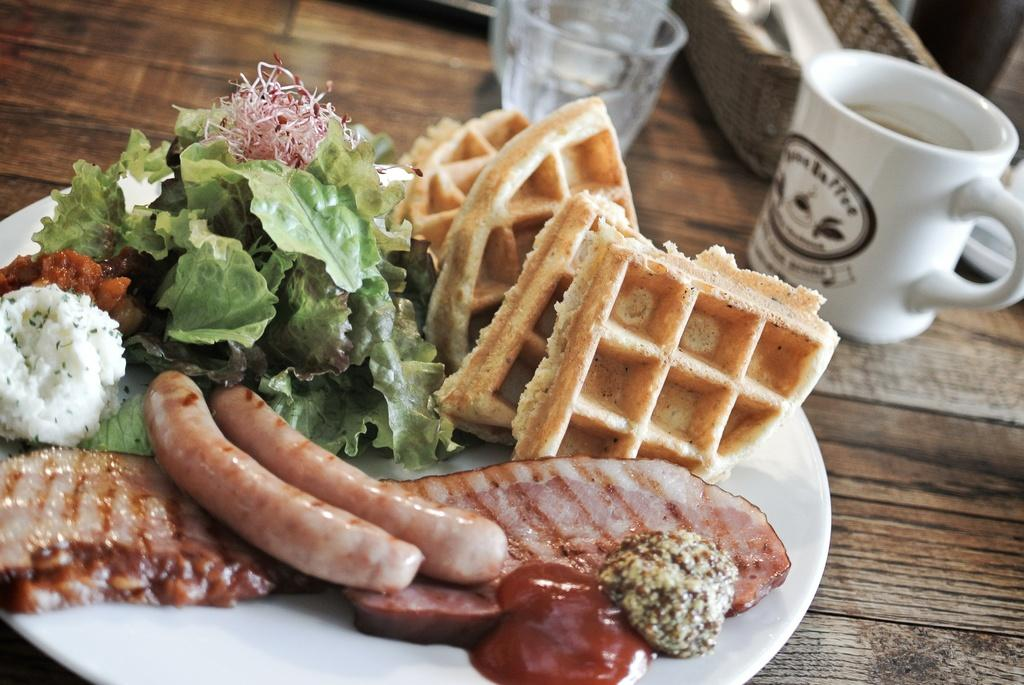What type of food items can be seen on the plate in the image? The specific food items are not mentioned, but there is a plate of food items in the image. What type of containers are present for holding liquids in the image? There are glasses and a cup in the image. What type of container is present for holding multiple items in the image? There is a basket in the image. Where are all these items located in the image? All of these items are on a table in the image. Can you see any goldfish swimming in the sand in the image? There is no sand or goldfish present in the image. 